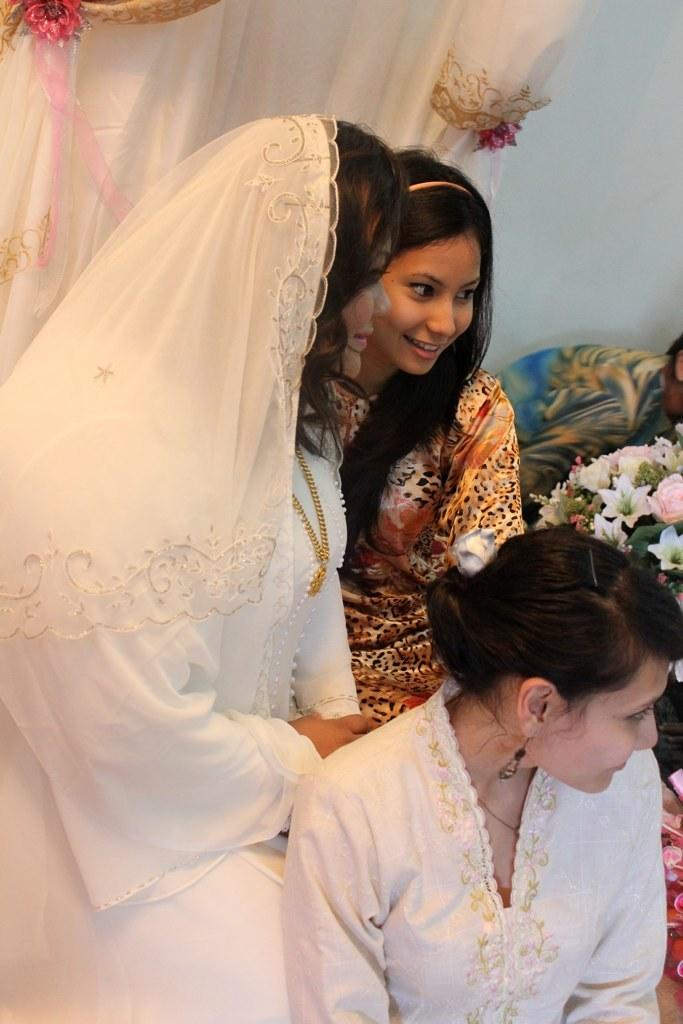How many people are present in the image? There are three people in the image. What can be observed about the clothing of the people in the image? The people are wearing different color dresses. What type of natural elements can be seen in the image? There are flowers visible in the image. What color is the curtain in the image? The curtain in the image is white. What is the color of the wall in the image? The wall in the image is white. Can you see a rabbit hopping on the white wall in the image? There is no rabbit present in the image, and the wall is not depicted as having any activity on it. 